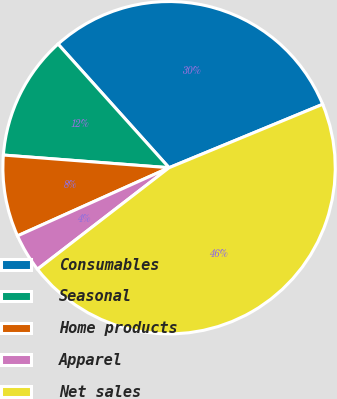Convert chart. <chart><loc_0><loc_0><loc_500><loc_500><pie_chart><fcel>Consumables<fcel>Seasonal<fcel>Home products<fcel>Apparel<fcel>Net sales<nl><fcel>30.41%<fcel>12.14%<fcel>7.94%<fcel>3.73%<fcel>45.77%<nl></chart> 